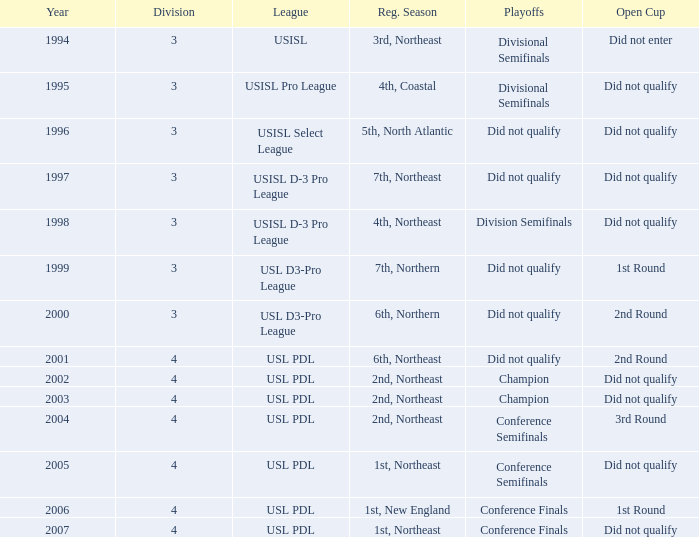Name the league for 2003 USL PDL. 